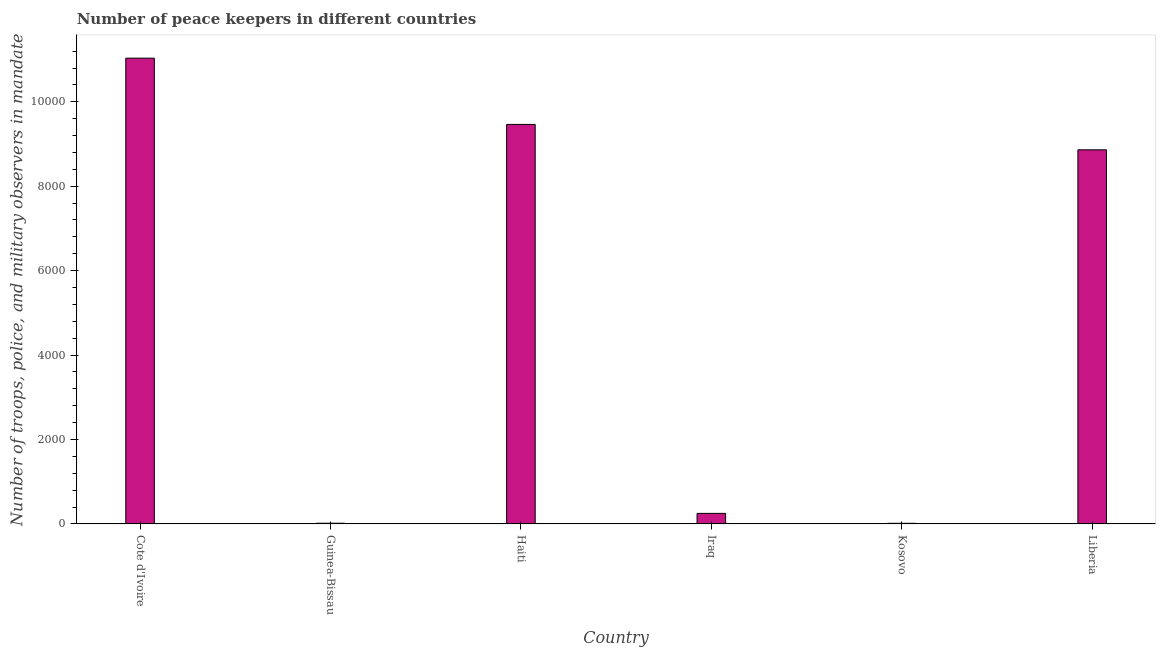What is the title of the graph?
Your response must be concise. Number of peace keepers in different countries. What is the label or title of the Y-axis?
Keep it short and to the point. Number of troops, police, and military observers in mandate. Across all countries, what is the maximum number of peace keepers?
Ensure brevity in your answer.  1.10e+04. In which country was the number of peace keepers maximum?
Your answer should be very brief. Cote d'Ivoire. In which country was the number of peace keepers minimum?
Provide a succinct answer. Kosovo. What is the sum of the number of peace keepers?
Offer a terse response. 2.96e+04. What is the difference between the number of peace keepers in Cote d'Ivoire and Kosovo?
Provide a succinct answer. 1.10e+04. What is the average number of peace keepers per country?
Your answer should be very brief. 4940. What is the median number of peace keepers?
Offer a very short reply. 4556.5. In how many countries, is the number of peace keepers greater than 2000 ?
Keep it short and to the point. 3. What is the ratio of the number of peace keepers in Cote d'Ivoire to that in Kosovo?
Your answer should be very brief. 689.56. What is the difference between the highest and the second highest number of peace keepers?
Offer a terse response. 1569. What is the difference between the highest and the lowest number of peace keepers?
Your response must be concise. 1.10e+04. In how many countries, is the number of peace keepers greater than the average number of peace keepers taken over all countries?
Your answer should be compact. 3. How many countries are there in the graph?
Your response must be concise. 6. Are the values on the major ticks of Y-axis written in scientific E-notation?
Provide a succinct answer. No. What is the Number of troops, police, and military observers in mandate of Cote d'Ivoire?
Give a very brief answer. 1.10e+04. What is the Number of troops, police, and military observers in mandate in Guinea-Bissau?
Your answer should be very brief. 18. What is the Number of troops, police, and military observers in mandate of Haiti?
Keep it short and to the point. 9464. What is the Number of troops, police, and military observers in mandate of Iraq?
Provide a short and direct response. 251. What is the Number of troops, police, and military observers in mandate in Liberia?
Offer a very short reply. 8862. What is the difference between the Number of troops, police, and military observers in mandate in Cote d'Ivoire and Guinea-Bissau?
Provide a succinct answer. 1.10e+04. What is the difference between the Number of troops, police, and military observers in mandate in Cote d'Ivoire and Haiti?
Offer a very short reply. 1569. What is the difference between the Number of troops, police, and military observers in mandate in Cote d'Ivoire and Iraq?
Provide a succinct answer. 1.08e+04. What is the difference between the Number of troops, police, and military observers in mandate in Cote d'Ivoire and Kosovo?
Make the answer very short. 1.10e+04. What is the difference between the Number of troops, police, and military observers in mandate in Cote d'Ivoire and Liberia?
Your response must be concise. 2171. What is the difference between the Number of troops, police, and military observers in mandate in Guinea-Bissau and Haiti?
Make the answer very short. -9446. What is the difference between the Number of troops, police, and military observers in mandate in Guinea-Bissau and Iraq?
Offer a terse response. -233. What is the difference between the Number of troops, police, and military observers in mandate in Guinea-Bissau and Liberia?
Provide a short and direct response. -8844. What is the difference between the Number of troops, police, and military observers in mandate in Haiti and Iraq?
Your answer should be very brief. 9213. What is the difference between the Number of troops, police, and military observers in mandate in Haiti and Kosovo?
Offer a very short reply. 9448. What is the difference between the Number of troops, police, and military observers in mandate in Haiti and Liberia?
Provide a short and direct response. 602. What is the difference between the Number of troops, police, and military observers in mandate in Iraq and Kosovo?
Your answer should be compact. 235. What is the difference between the Number of troops, police, and military observers in mandate in Iraq and Liberia?
Make the answer very short. -8611. What is the difference between the Number of troops, police, and military observers in mandate in Kosovo and Liberia?
Your response must be concise. -8846. What is the ratio of the Number of troops, police, and military observers in mandate in Cote d'Ivoire to that in Guinea-Bissau?
Make the answer very short. 612.94. What is the ratio of the Number of troops, police, and military observers in mandate in Cote d'Ivoire to that in Haiti?
Offer a terse response. 1.17. What is the ratio of the Number of troops, police, and military observers in mandate in Cote d'Ivoire to that in Iraq?
Provide a succinct answer. 43.96. What is the ratio of the Number of troops, police, and military observers in mandate in Cote d'Ivoire to that in Kosovo?
Provide a short and direct response. 689.56. What is the ratio of the Number of troops, police, and military observers in mandate in Cote d'Ivoire to that in Liberia?
Offer a terse response. 1.25. What is the ratio of the Number of troops, police, and military observers in mandate in Guinea-Bissau to that in Haiti?
Give a very brief answer. 0. What is the ratio of the Number of troops, police, and military observers in mandate in Guinea-Bissau to that in Iraq?
Keep it short and to the point. 0.07. What is the ratio of the Number of troops, police, and military observers in mandate in Guinea-Bissau to that in Kosovo?
Your answer should be very brief. 1.12. What is the ratio of the Number of troops, police, and military observers in mandate in Guinea-Bissau to that in Liberia?
Provide a short and direct response. 0. What is the ratio of the Number of troops, police, and military observers in mandate in Haiti to that in Iraq?
Provide a short and direct response. 37.7. What is the ratio of the Number of troops, police, and military observers in mandate in Haiti to that in Kosovo?
Ensure brevity in your answer.  591.5. What is the ratio of the Number of troops, police, and military observers in mandate in Haiti to that in Liberia?
Your response must be concise. 1.07. What is the ratio of the Number of troops, police, and military observers in mandate in Iraq to that in Kosovo?
Your answer should be very brief. 15.69. What is the ratio of the Number of troops, police, and military observers in mandate in Iraq to that in Liberia?
Make the answer very short. 0.03. What is the ratio of the Number of troops, police, and military observers in mandate in Kosovo to that in Liberia?
Keep it short and to the point. 0. 